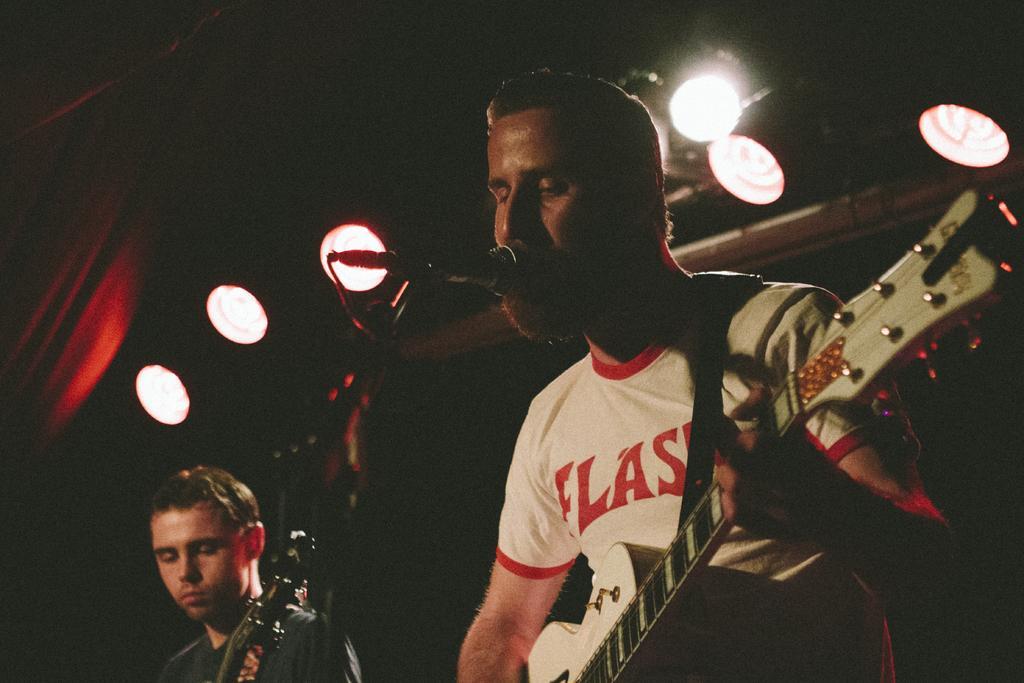In one or two sentences, can you explain what this image depicts? In the image we can see there is a man who is holding guitar in his hand and another man is also holding a guitar in his hand. 